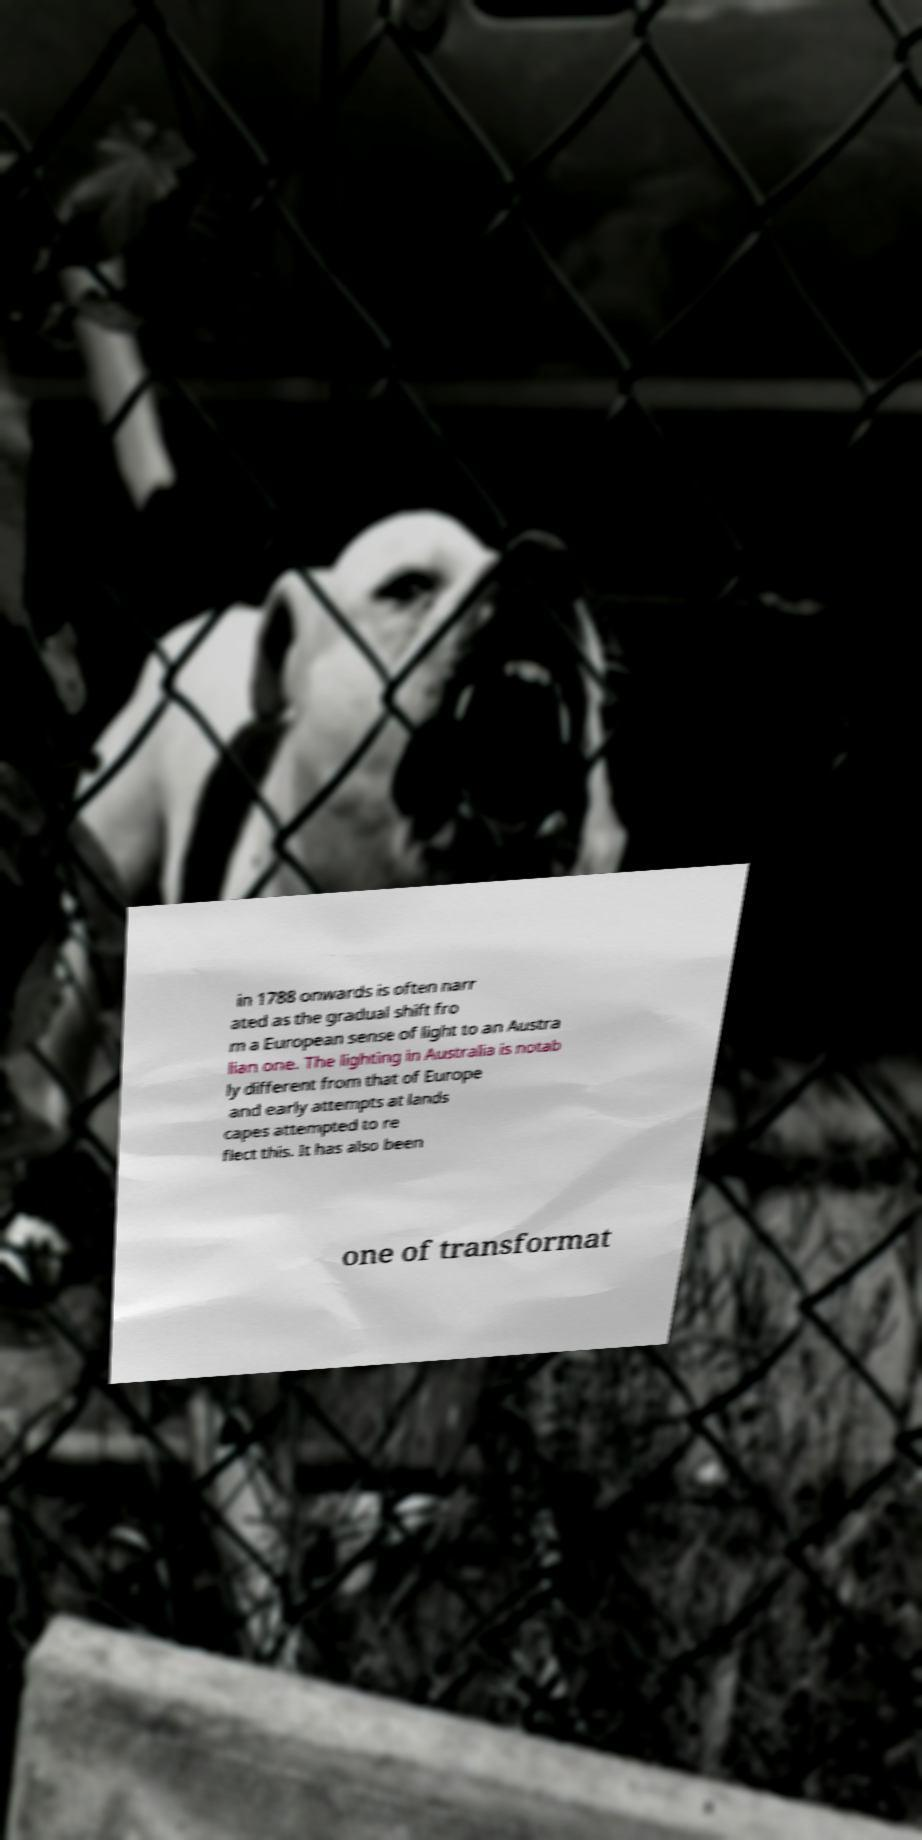Please identify and transcribe the text found in this image. in 1788 onwards is often narr ated as the gradual shift fro m a European sense of light to an Austra lian one. The lighting in Australia is notab ly different from that of Europe and early attempts at lands capes attempted to re flect this. It has also been one of transformat 